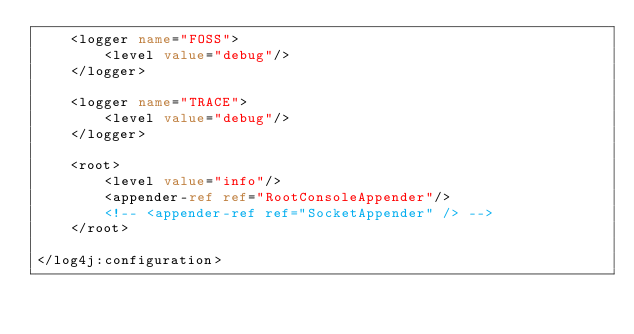Convert code to text. <code><loc_0><loc_0><loc_500><loc_500><_XML_>    <logger name="FOSS">
        <level value="debug"/>
    </logger>

    <logger name="TRACE">
        <level value="debug"/>
    </logger>

    <root>
        <level value="info"/>
        <appender-ref ref="RootConsoleAppender"/>
        <!-- <appender-ref ref="SocketAppender" /> -->
    </root>

</log4j:configuration></code> 